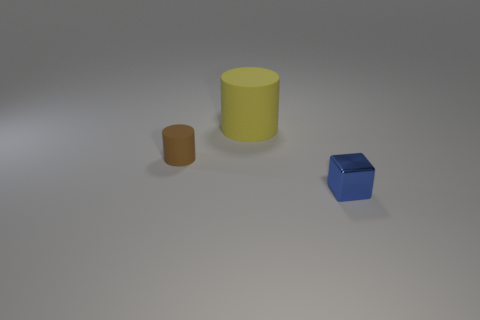Can you tell me the colors of the objects in the image? Certainly! In the image, there are three objects: a large yellow cylinder, a smaller brown cylinder, and a blue cube. 